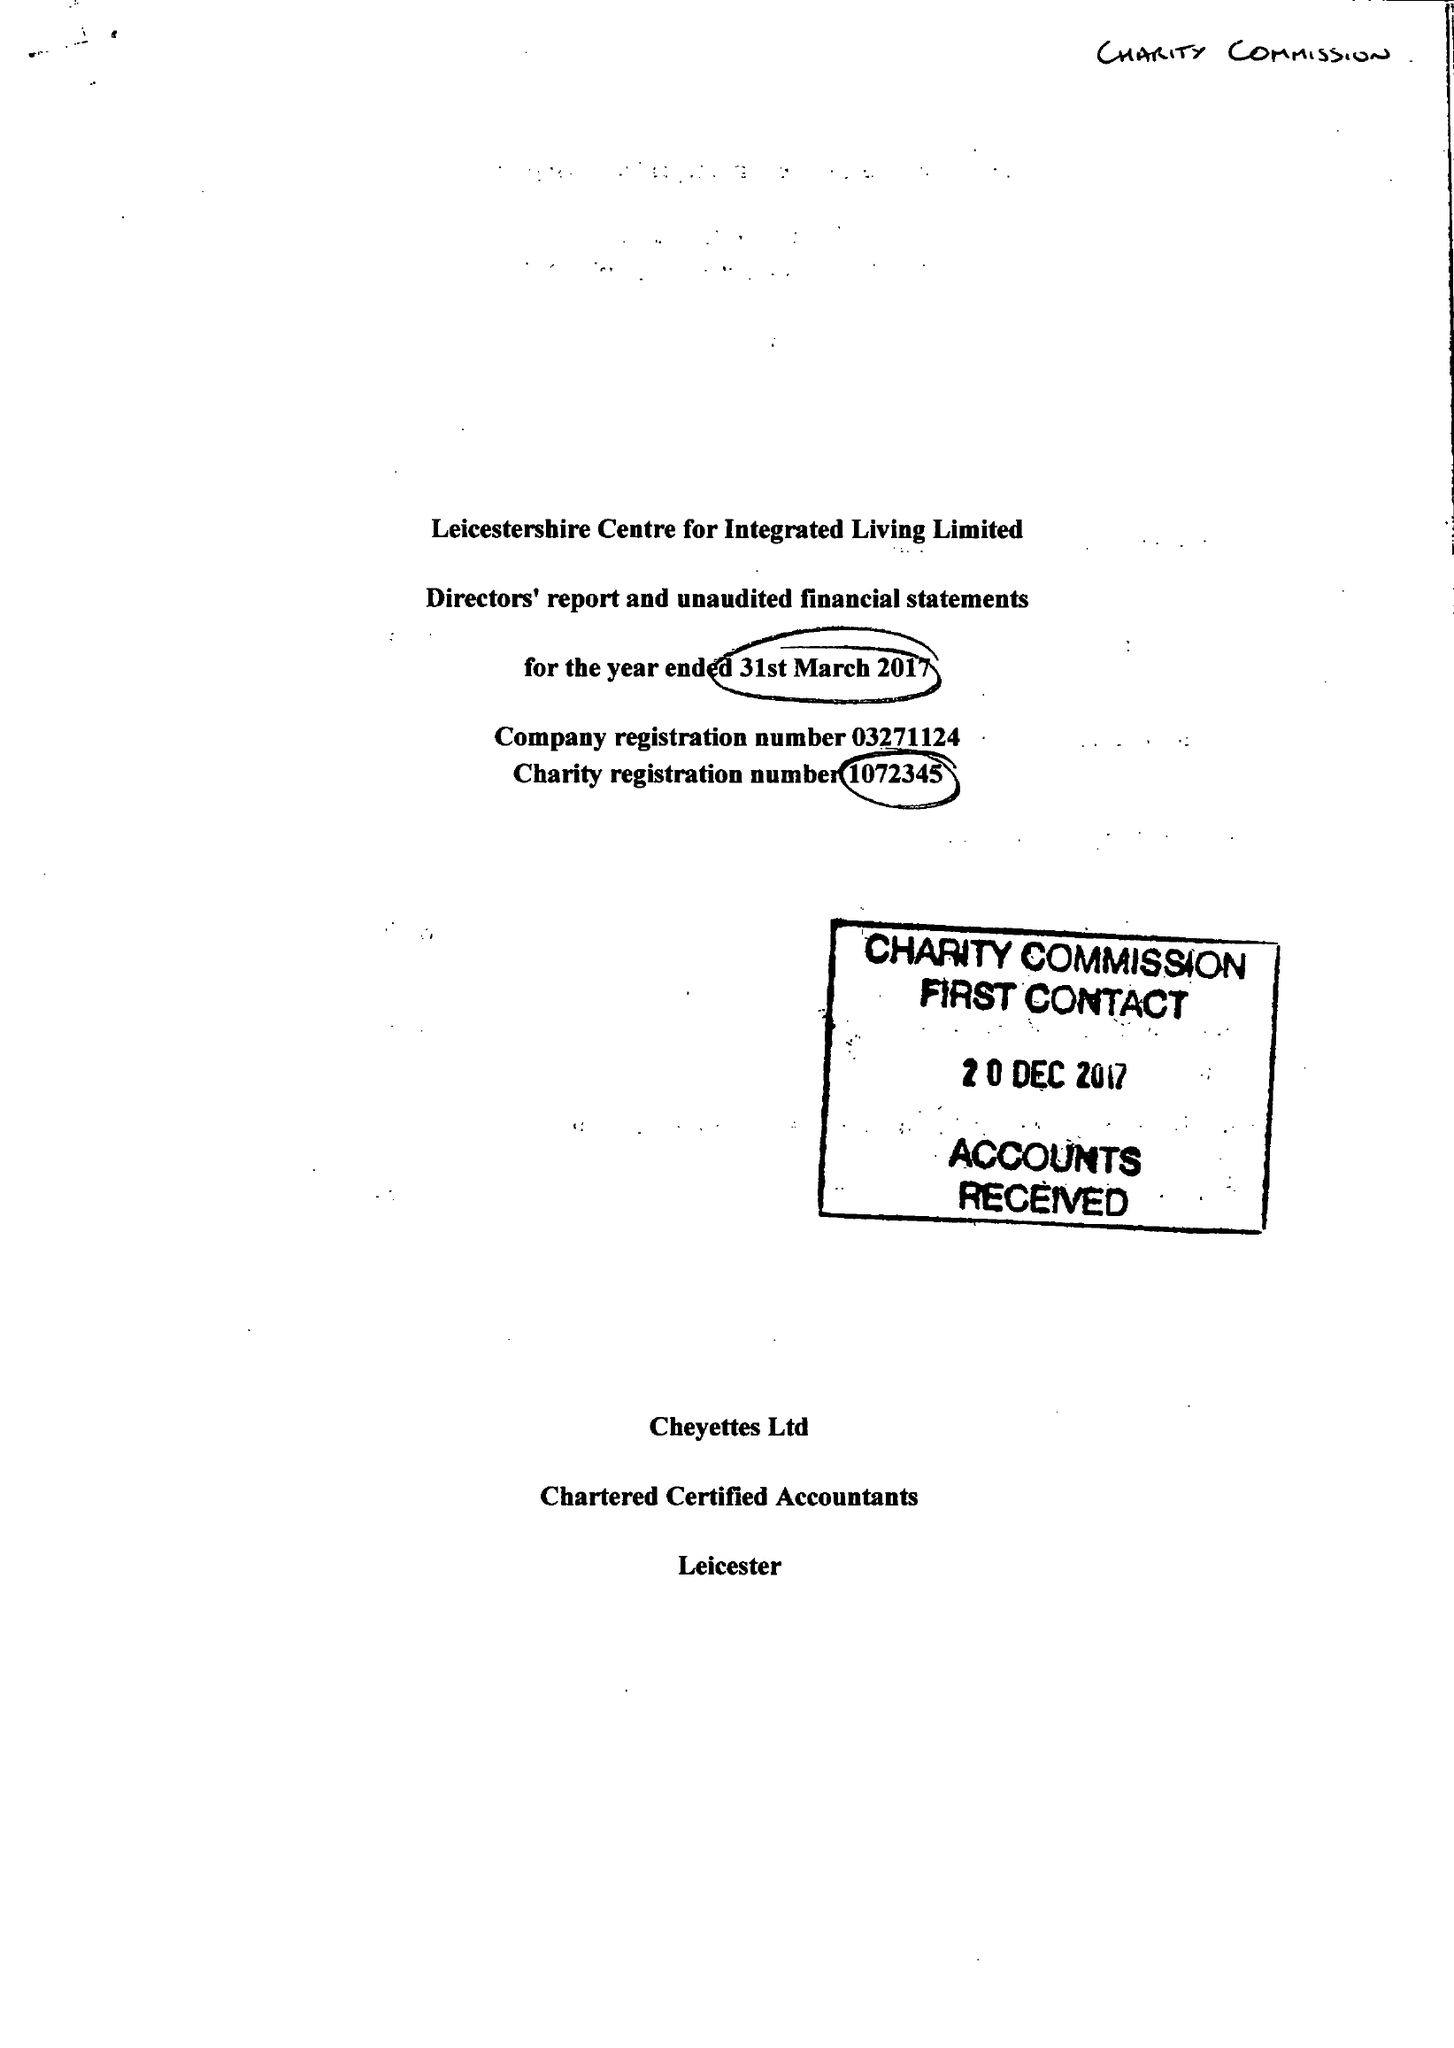What is the value for the address__postcode?
Answer the question using a single word or phrase. LE3 5PA 